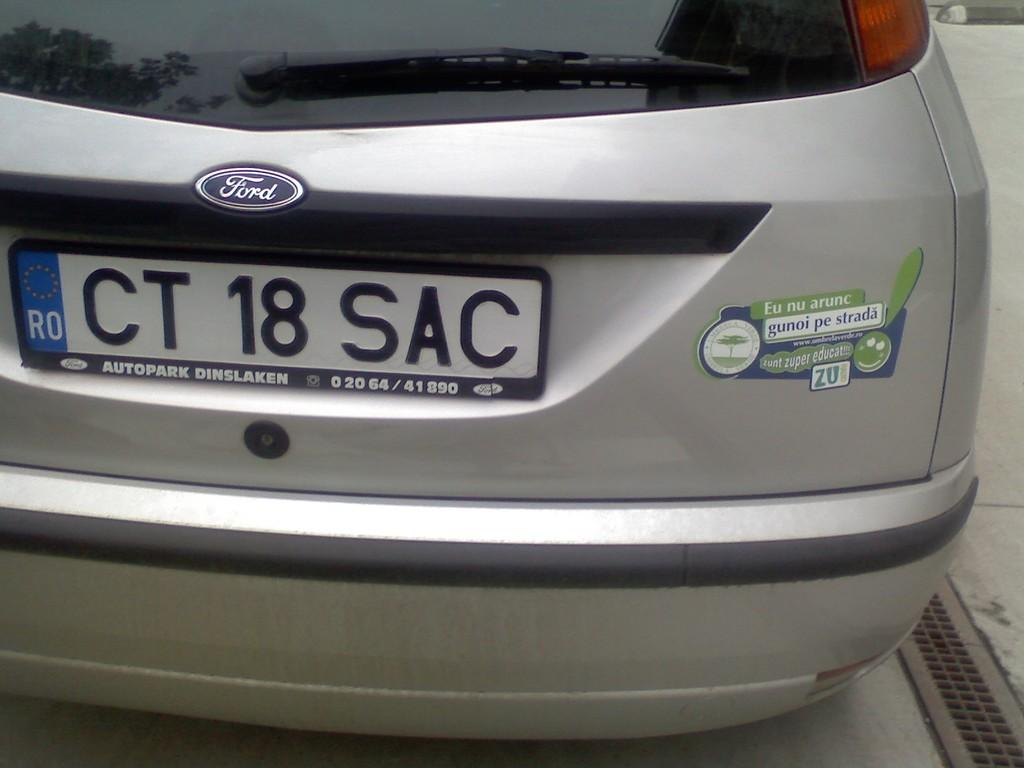<image>
Relay a brief, clear account of the picture shown. Silver Ford car with a plate that says CT18SAC. 